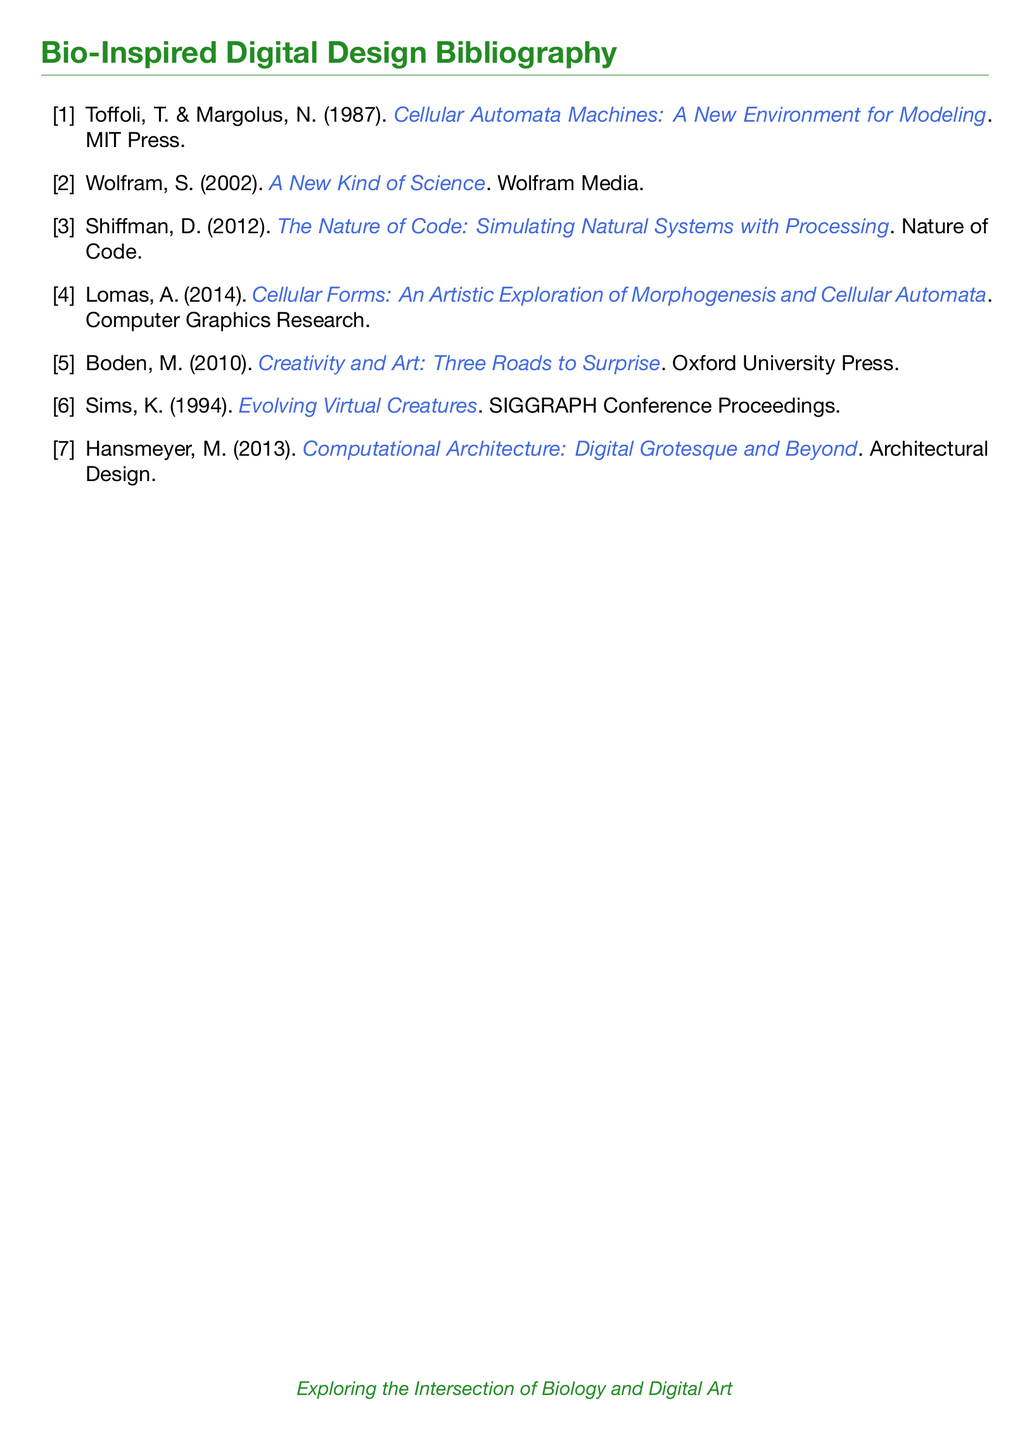What is the title of the first reference? The first reference in the bibliography is "Cellular Automata Machines: A New Environment for Modeling".
Answer: Cellular Automata Machines: A New Environment for Modeling How many authors are listed for the second reference? The second reference is written by one author, Stephen Wolfram.
Answer: 1 What year was "The Nature of Code" published? The publication year of "The Nature of Code" is 2012.
Answer: 2012 Which publisher produced "Creativity and Art: Three Roads to Surprise"? The bibliography indicates that "Creativity and Art: Three Roads to Surprise" was published by Oxford University Press.
Answer: Oxford University Press What is the focus of the work by Lomas in 2014? Lomas's 2014 work is focused on the artistic exploration of morphogenesis and cellular automata.
Answer: Artistic exploration of morphogenesis and cellular automata Which reference discusses evolving virtual creatures? The reference that discusses evolving virtual creatures is authored by K. Sims in 1994.
Answer: K. Sims, 1994 What color is used for the bibliography title? The title of the bibliography is colored biogreen.
Answer: biogreen How many references are in the document? The document contains a total of seven references in the bibliography.
Answer: 7 Which document type is this bibliography classified as? This document is classified as a bibliography.
Answer: bibliography 